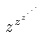Convert formula to latex. <formula><loc_0><loc_0><loc_500><loc_500>z ^ { z ^ { z ^ { \cdot ^ { \cdot ^ { \cdot } } } } }</formula> 